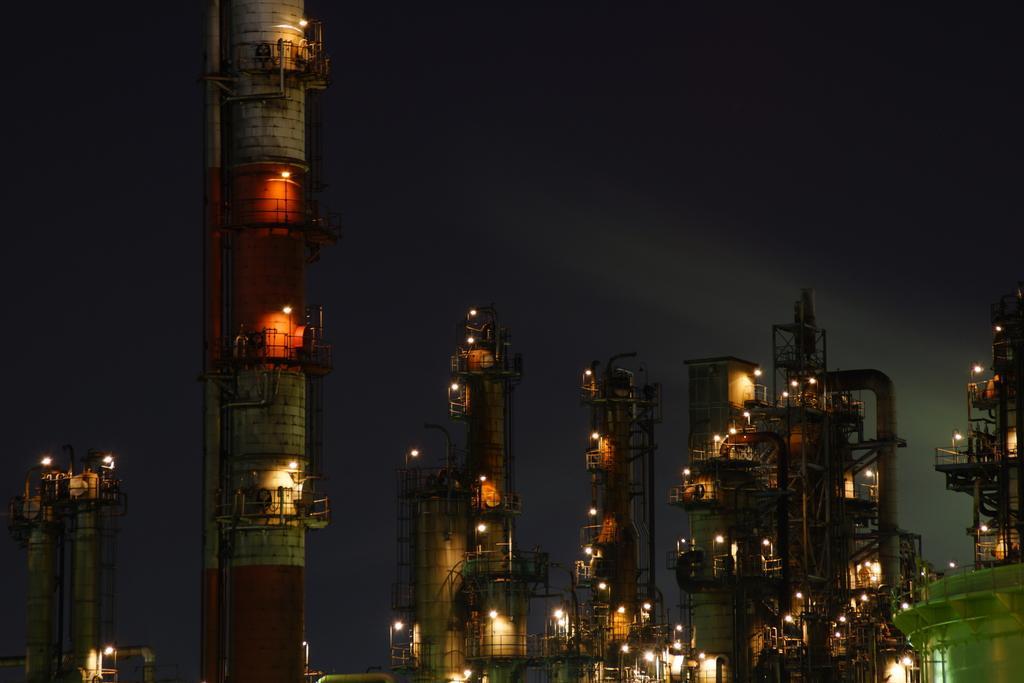In one or two sentences, can you explain what this image depicts? This picture contains many buildings and towers. We see lights in the buildings. In the background, it is black in color. This picture is clicked in the dark. 